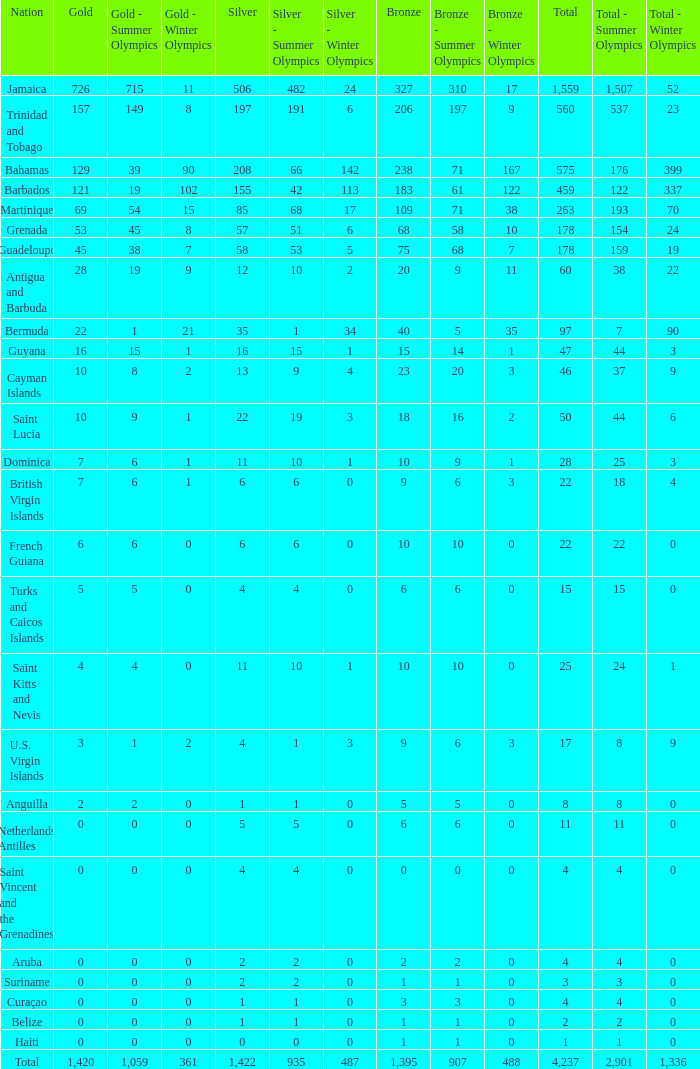Give me the full table as a dictionary. {'header': ['Nation', 'Gold', 'Gold - Summer Olympics', 'Gold - Winter Olympics', 'Silver', 'Silver - Summer Olympics', 'Silver - Winter Olympics', 'Bronze', 'Bronze - Summer Olympics', 'Bronze - Winter Olympics', 'Total', 'Total - Summer Olympics', 'Total - Winter Olympics '], 'rows': [['Jamaica', '726', '715', '11', '506', '482', '24', '327', '310', '17', '1,559', '1,507', '52'], ['Trinidad and Tobago', '157', '149', '8', '197', '191', '6', '206', '197', '9', '560', '537', '23'], ['Bahamas', '129', '39', '90', '208', '66', '142', '238', '71', '167', '575', '176', '399'], ['Barbados', '121', '19', '102', '155', '42', '113', '183', '61', '122', '459', '122', '337'], ['Martinique', '69', '54', '15', '85', '68', '17', '109', '71', '38', '263', '193', '70'], ['Grenada', '53', '45', '8', '57', '51', '6', '68', '58', '10', '178', '154', '24'], ['Guadeloupe', '45', '38', '7', '58', '53', '5', '75', '68', '7', '178', '159', '19'], ['Antigua and Barbuda', '28', '19', '9', '12', '10', '2', '20', '9', '11', '60', '38', '22'], ['Bermuda', '22', '1', '21', '35', '1', '34', '40', '5', '35', '97', '7', '90'], ['Guyana', '16', '15', '1', '16', '15', '1', '15', '14', '1', '47', '44', '3'], ['Cayman Islands', '10', '8', '2', '13', '9', '4', '23', '20', '3', '46', '37', '9'], ['Saint Lucia', '10', '9', '1', '22', '19', '3', '18', '16', '2', '50', '44', '6'], ['Dominica', '7', '6', '1', '11', '10', '1', '10', '9', '1', '28', '25', '3'], ['British Virgin Islands', '7', '6', '1', '6', '6', '0', '9', '6', '3', '22', '18', '4'], ['French Guiana', '6', '6', '0', '6', '6', '0', '10', '10', '0', '22', '22', '0'], ['Turks and Caicos Islands', '5', '5', '0', '4', '4', '0', '6', '6', '0', '15', '15', '0'], ['Saint Kitts and Nevis', '4', '4', '0', '11', '10', '1', '10', '10', '0', '25', '24', '1'], ['U.S. Virgin Islands', '3', '1', '2', '4', '1', '3', '9', '6', '3', '17', '8', '9'], ['Anguilla', '2', '2', '0', '1', '1', '0', '5', '5', '0', '8', '8', '0'], ['Netherlands Antilles', '0', '0', '0', '5', '5', '0', '6', '6', '0', '11', '11', '0'], ['Saint Vincent and the Grenadines', '0', '0', '0', '4', '4', '0', '0', '0', '0', '4', '4', '0'], ['Aruba', '0', '0', '0', '2', '2', '0', '2', '2', '0', '4', '4', '0'], ['Suriname', '0', '0', '0', '2', '2', '0', '1', '1', '0', '3', '3', '0'], ['Curaçao', '0', '0', '0', '1', '1', '0', '3', '3', '0', '4', '4', '0'], ['Belize', '0', '0', '0', '1', '1', '0', '1', '1', '0', '2', '2', '0'], ['Haiti', '0', '0', '0', '0', '0', '0', '1', '1', '0', '1', '1', '0'], ['Total', '1,420', '1,059', '361', '1,422', '935', '487', '1,395', '907', '488', '4,237', '2,901', '1,336']]} What Nation has a Bronze that is smaller than 10 with a Silver of 5? Netherlands Antilles. 